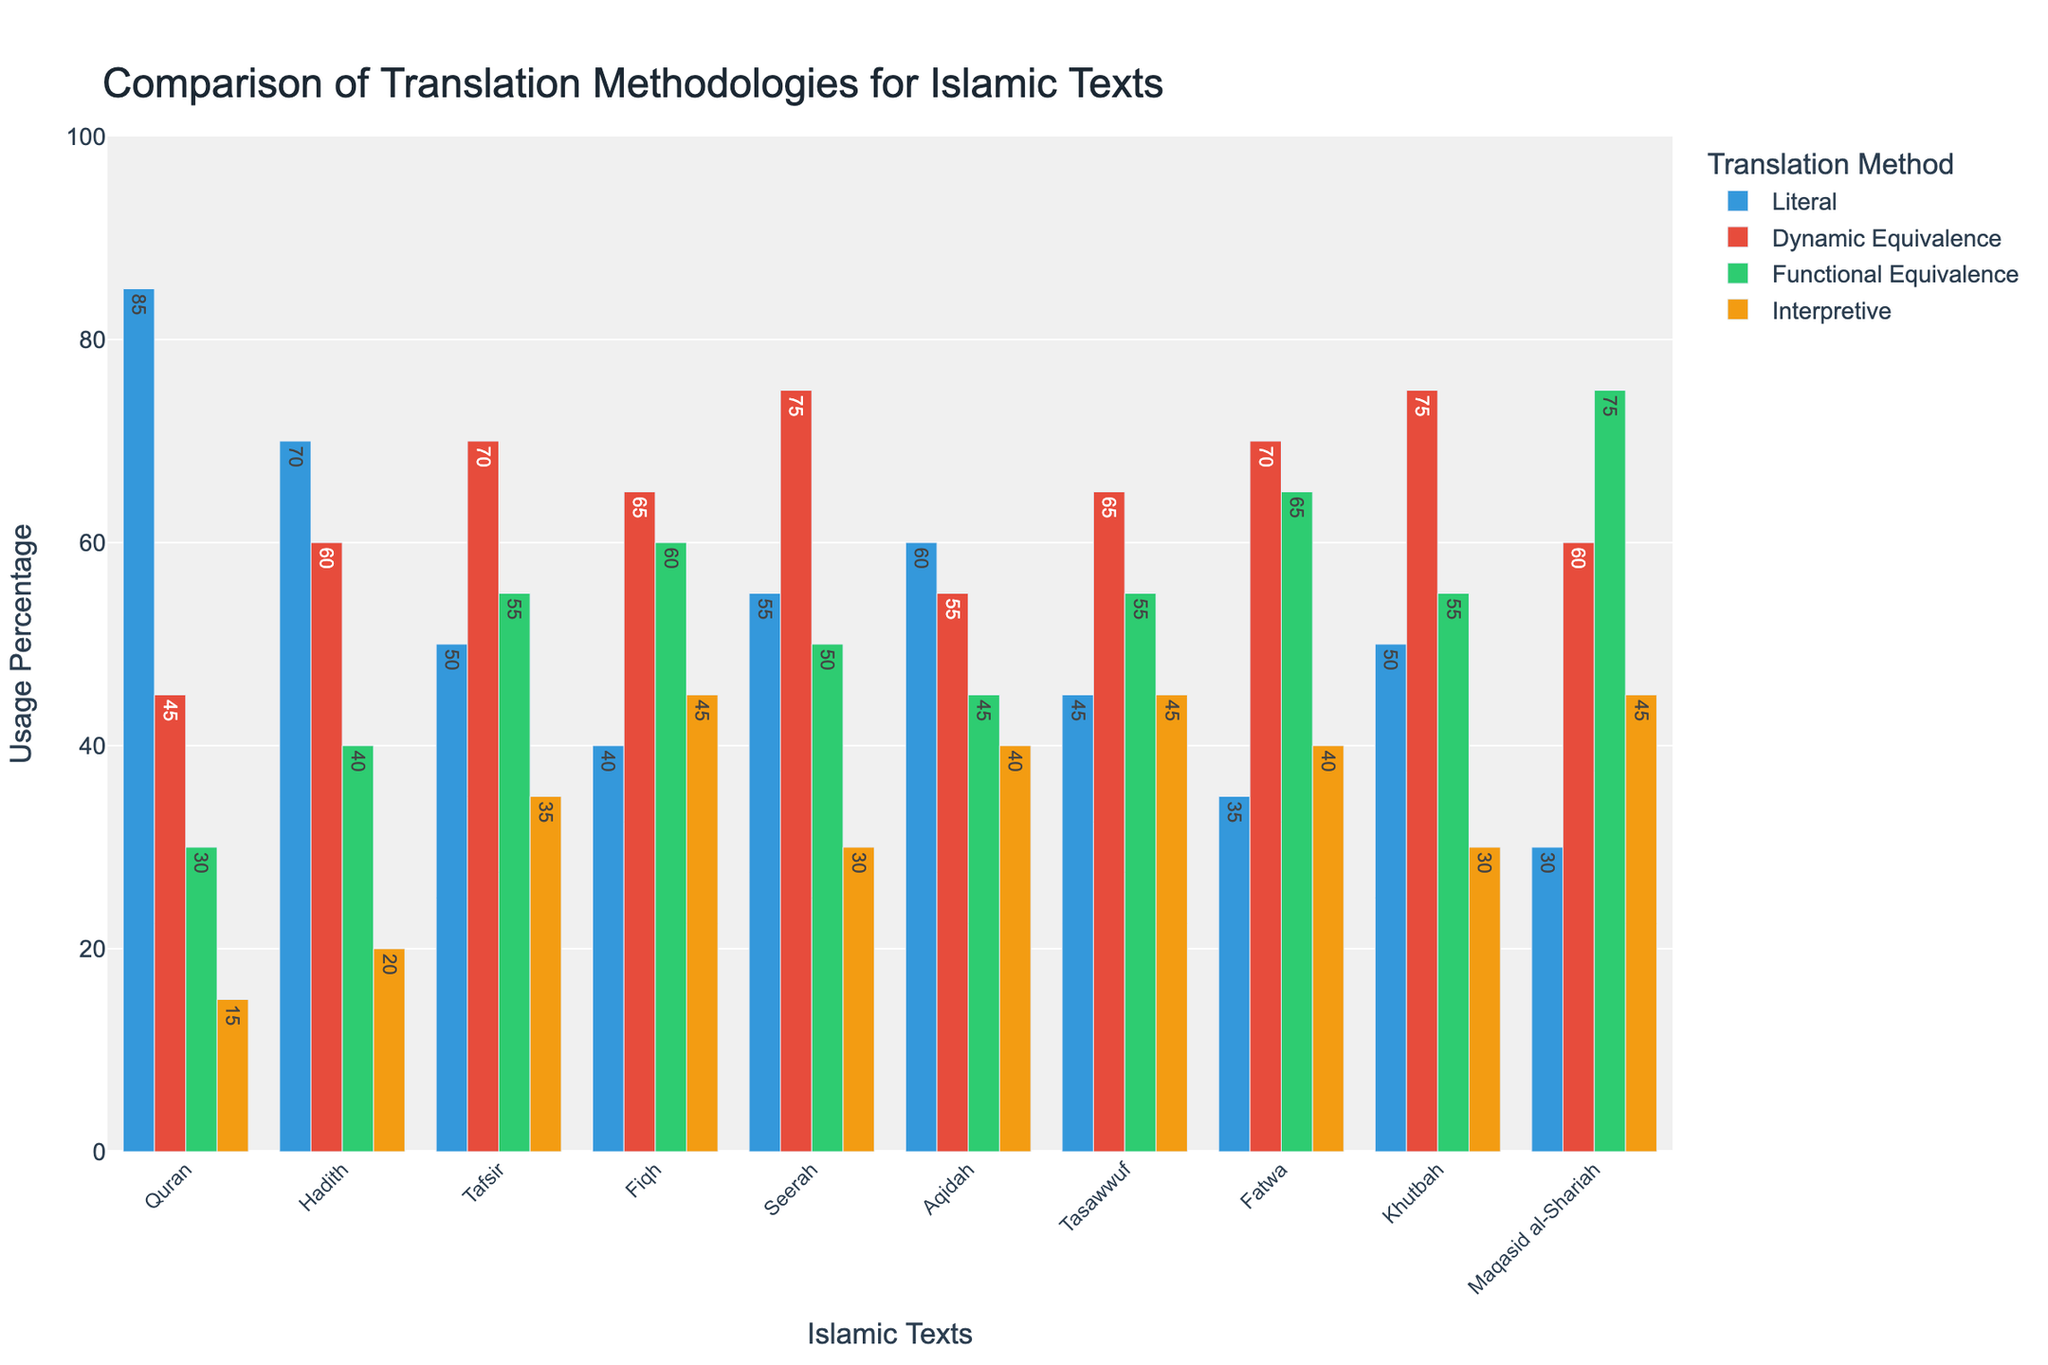What is the most commonly used translation methodology for the Quran? The highest bar in the 'Quran' group indicates the most commonly used translation methodology. By observing the bars, the Literal method is the highest for the Quran.
Answer: Literal Which text has the highest usage of the Interpretive translation methodology? By identifying and comparing the height of the yellow-colored bars for Interpretive translation across all texts, we observe that Maqasid al-Shariah has the highest value.
Answer: Maqasid al-Shariah How much more is the usage percentage of Functional Equivalence compared to Literal for Fiqh? For Fiqh, Functional Equivalence has a value of 60, and Literal has 40. The difference between them is 60 - 40 = 20.
Answer: 20 What is the total usage percentage of all translation methodologies for Seerah? By summing up all the values for Seerah (Literal: 55, Dynamic Equivalence: 75, Functional Equivalence: 50, Interpretive: 30), the total is 55 + 75 + 50 + 30 = 210.
Answer: 210 Which two texts have the closest usage percentages for Dynamic Equivalence? By comparing the red bars (Dynamic Equivalence) across all texts, Tafsir and Fi'qh both have 65, making them the closest.
Answer: Tafsir and Fiqh What is the combined percentage of Interpretive methodology usage for Hadith and Fatwa? Sum the values for Interpretive (yellow bars) for Hadith (20) and Fatwa (40), resulting in 20 + 40 = 60.
Answer: 60 Which translation methodology has the highest variance across all texts? By examining the range and spread of the bars for each methodology, Literal translation shows a wide range of values from 30 to 85, indicating higher variance.
Answer: Literal What is the difference in the usage percentage of Dynamic Equivalence and Interpretive for Tasawwuf? The Dynamic Equivalence for Tasawwuf is 65, and the Interpretive is 45. The difference is 65 - 45 = 20.
Answer: 20 